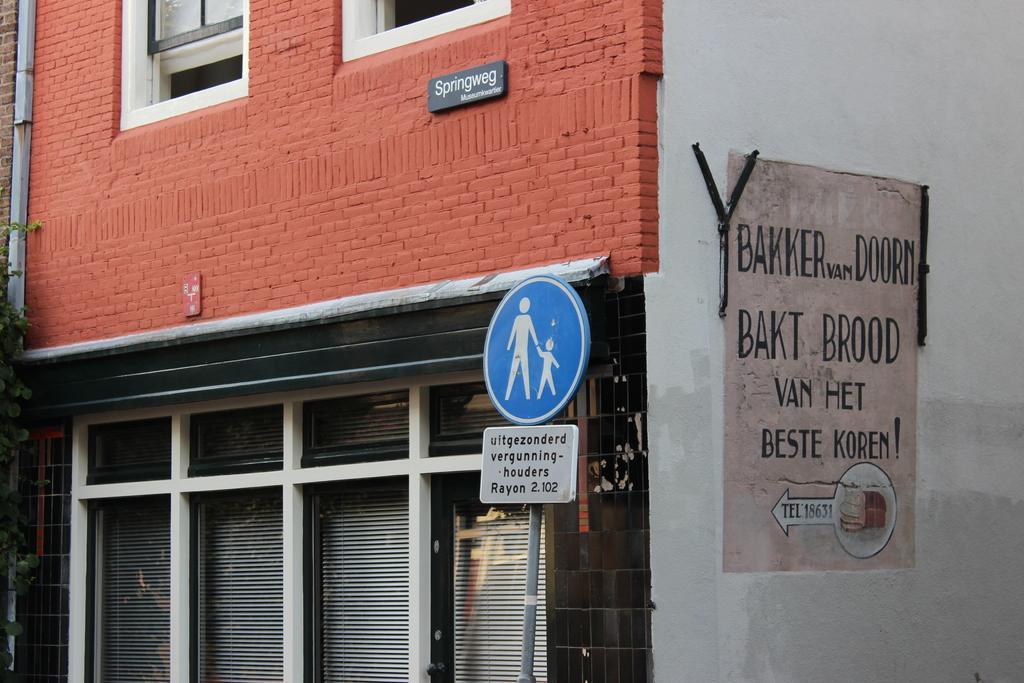In one or two sentences, can you explain what this image depicts? In this image I can see a building, board and windows. This image is taken may be during a day. 